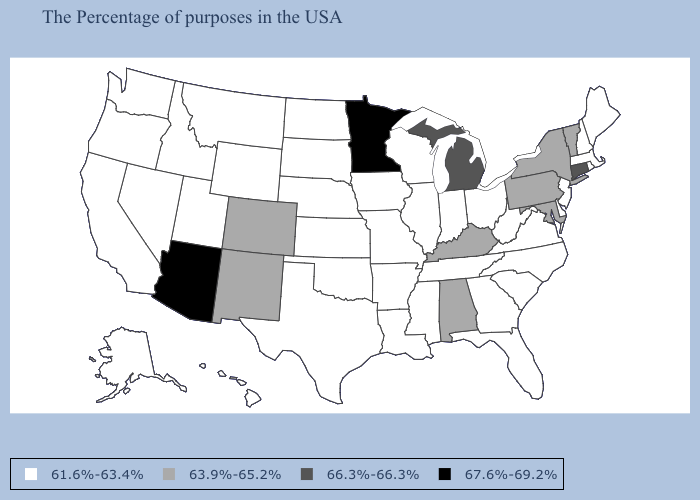Name the states that have a value in the range 66.3%-66.3%?
Be succinct. Connecticut, Michigan. Does Arizona have the lowest value in the USA?
Keep it brief. No. What is the highest value in the USA?
Quick response, please. 67.6%-69.2%. Is the legend a continuous bar?
Concise answer only. No. Does Pennsylvania have the highest value in the Northeast?
Answer briefly. No. Does Kentucky have the highest value in the South?
Quick response, please. Yes. Does Oregon have a lower value than Maryland?
Answer briefly. Yes. Name the states that have a value in the range 67.6%-69.2%?
Be succinct. Minnesota, Arizona. Does South Dakota have the same value as Washington?
Quick response, please. Yes. What is the highest value in states that border California?
Write a very short answer. 67.6%-69.2%. What is the value of Wisconsin?
Short answer required. 61.6%-63.4%. Does Arizona have the highest value in the USA?
Answer briefly. Yes. Does Connecticut have a higher value than Michigan?
Short answer required. No. What is the value of Pennsylvania?
Quick response, please. 63.9%-65.2%. Name the states that have a value in the range 66.3%-66.3%?
Answer briefly. Connecticut, Michigan. 